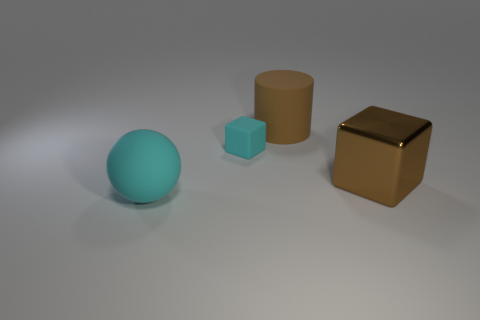There is a matte object that is the same size as the ball; what color is it?
Ensure brevity in your answer.  Brown. How big is the rubber ball?
Your answer should be compact. Large. Are the cyan thing that is behind the large cyan object and the brown cube made of the same material?
Keep it short and to the point. No. Does the shiny object have the same shape as the small cyan thing?
Provide a short and direct response. Yes. There is a big brown thing right of the brown thing behind the cyan rubber thing on the right side of the large cyan thing; what shape is it?
Provide a succinct answer. Cube. Do the big object on the left side of the large matte cylinder and the thing that is behind the small cyan matte object have the same shape?
Ensure brevity in your answer.  No. Is there a small green block that has the same material as the big cyan ball?
Keep it short and to the point. No. There is a large matte object that is behind the cube that is in front of the small object behind the cyan ball; what is its color?
Your answer should be compact. Brown. Do the cyan object on the right side of the big cyan rubber ball and the brown thing that is in front of the large cylinder have the same material?
Offer a terse response. No. What is the shape of the large thing in front of the big brown metal block?
Keep it short and to the point. Sphere. 